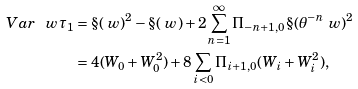Convert formula to latex. <formula><loc_0><loc_0><loc_500><loc_500>V a r _ { \ } w \tau _ { 1 } & = \S ( \ w ) ^ { 2 } - \S ( \ w ) + 2 \sum _ { n = 1 } ^ { \infty } \Pi _ { - n + 1 , 0 } \S ( \theta ^ { - n } \ w ) ^ { 2 } \\ & = 4 ( W _ { 0 } + W _ { 0 } ^ { 2 } ) + 8 \sum _ { i < 0 } \Pi _ { i + 1 , 0 } ( W _ { i } + W _ { i } ^ { 2 } ) ,</formula> 